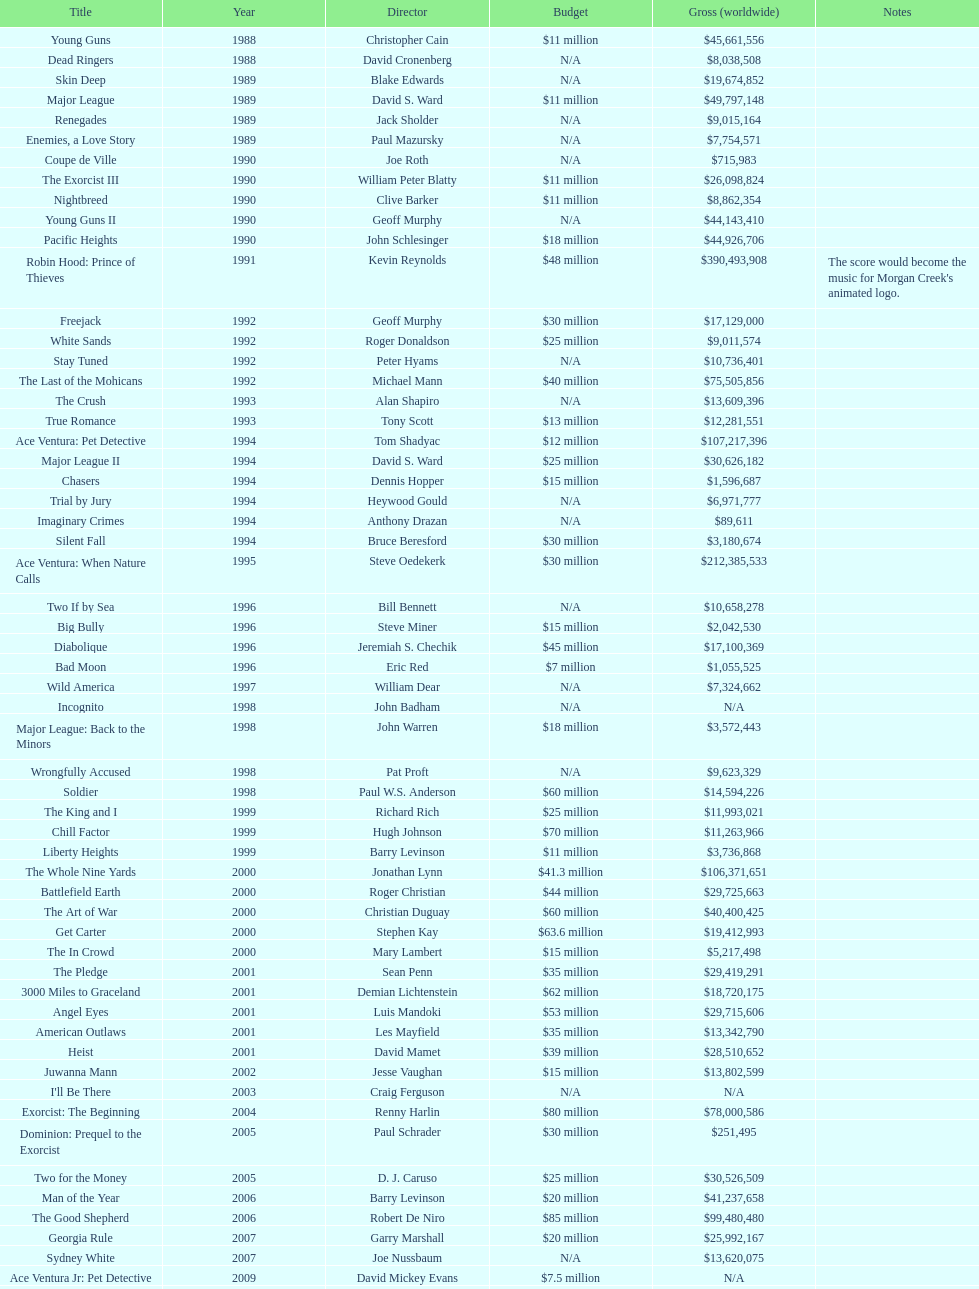What was the last movie morgan creek made for a budget under thirty million? Ace Ventura Jr: Pet Detective. 